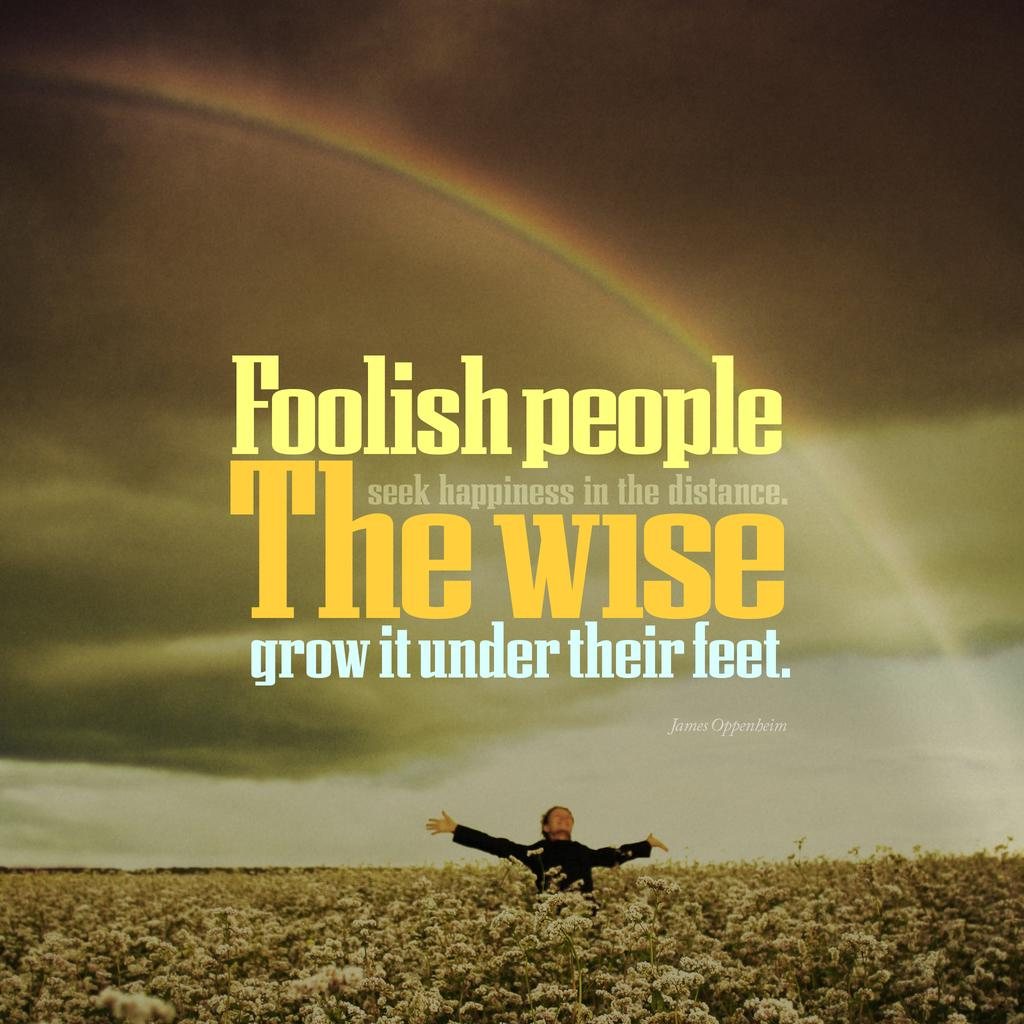<image>
Render a clear and concise summary of the photo. A man in a field album cover with the name James Oppenheim on the cover. 